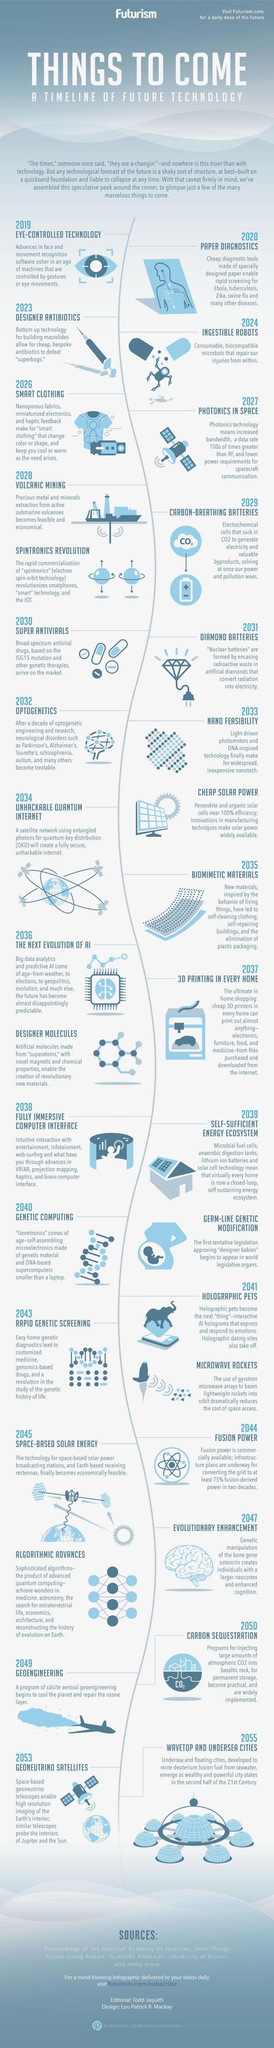Mention a couple of crucial points in this snapshot. In 2024, it is expected that ingestible robots will be deployed to repair injuries within the body, By 2035, it is expected that biomimetic materials will be developed to eliminate plastic packaging. These materials will be designed to mimic natural systems and biodegrade in an environmentally friendly manner. This innovation will significantly reduce the amount of plastic waste that ends up in our oceans and other ecosystems. It is a promising solution to a pressing environmental issue, and it is exciting to see the progress that is being made in this field. It is expected that in the field of genetics, a technology revolution known as "genetic computing" will occur in the year 2040. In 2041, the space field is expected to undergo a technology revolution with the introduction of microwave rockets, which will revolutionize space travel and exploration. The next evolution of AI is estimated to occur in 2036. 